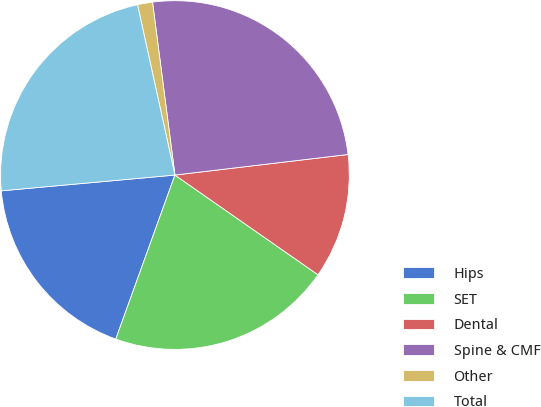Convert chart to OTSL. <chart><loc_0><loc_0><loc_500><loc_500><pie_chart><fcel>Hips<fcel>SET<fcel>Dental<fcel>Spine & CMF<fcel>Other<fcel>Total<nl><fcel>18.05%<fcel>20.82%<fcel>11.57%<fcel>25.17%<fcel>1.39%<fcel>23.0%<nl></chart> 